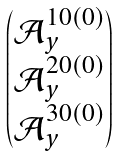Convert formula to latex. <formula><loc_0><loc_0><loc_500><loc_500>\begin{pmatrix} \mathcal { A } _ { y } ^ { 1 0 ( 0 ) } \\ \mathcal { A } _ { y } ^ { 2 0 ( 0 ) } \\ \mathcal { A } _ { y } ^ { 3 0 ( 0 ) } \end{pmatrix}</formula> 